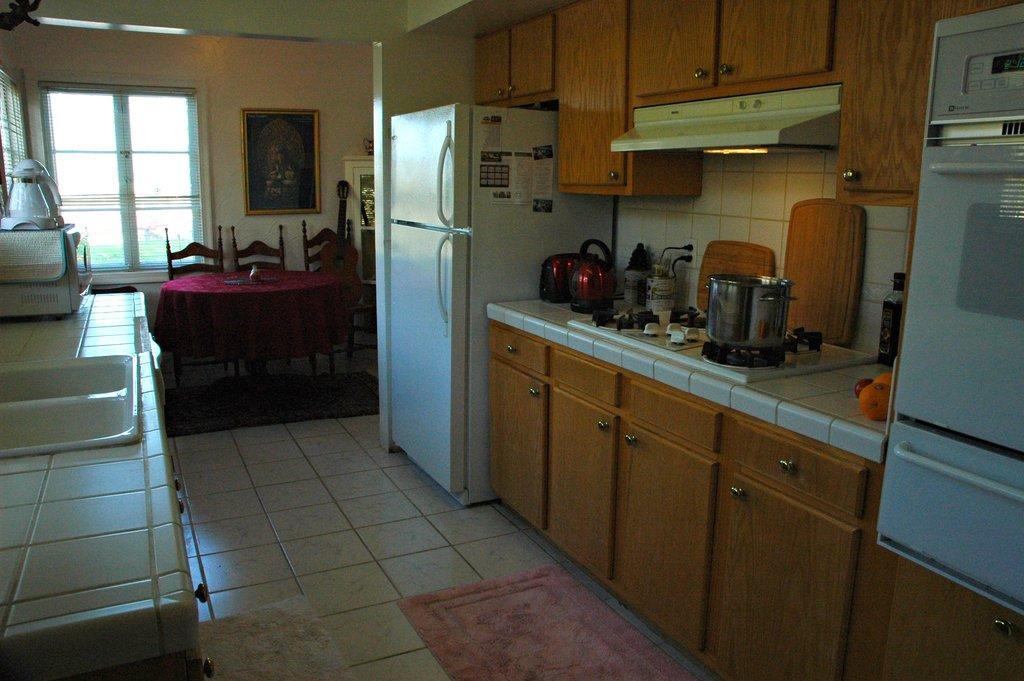Please provide a concise description of this image. In this image, we can see the interior view of a room. We can see the ground with some mats. We can also see the wall with a frame and some windows. We can see a table covered with a cloth and some objects are on it. We can see some chairs and the refrigerator. We can also see an object on the right. We can also see some cupboards and some objects on the kitchen platform. 